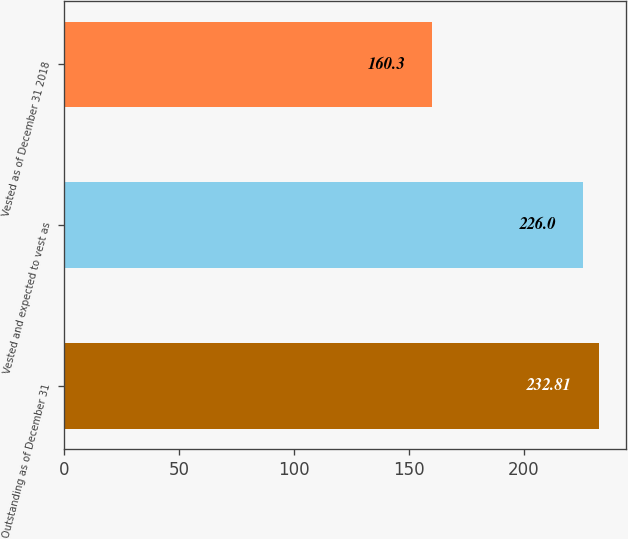<chart> <loc_0><loc_0><loc_500><loc_500><bar_chart><fcel>Outstanding as of December 31<fcel>Vested and expected to vest as<fcel>Vested as of December 31 2018<nl><fcel>232.81<fcel>226<fcel>160.3<nl></chart> 